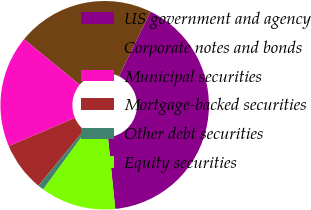Convert chart to OTSL. <chart><loc_0><loc_0><loc_500><loc_500><pie_chart><fcel>US government and agency<fcel>Corporate notes and bonds<fcel>Municipal securities<fcel>Mortgage-backed securities<fcel>Other debt securities<fcel>Equity securities<nl><fcel>41.13%<fcel>21.35%<fcel>17.33%<fcel>7.63%<fcel>0.92%<fcel>11.65%<nl></chart> 